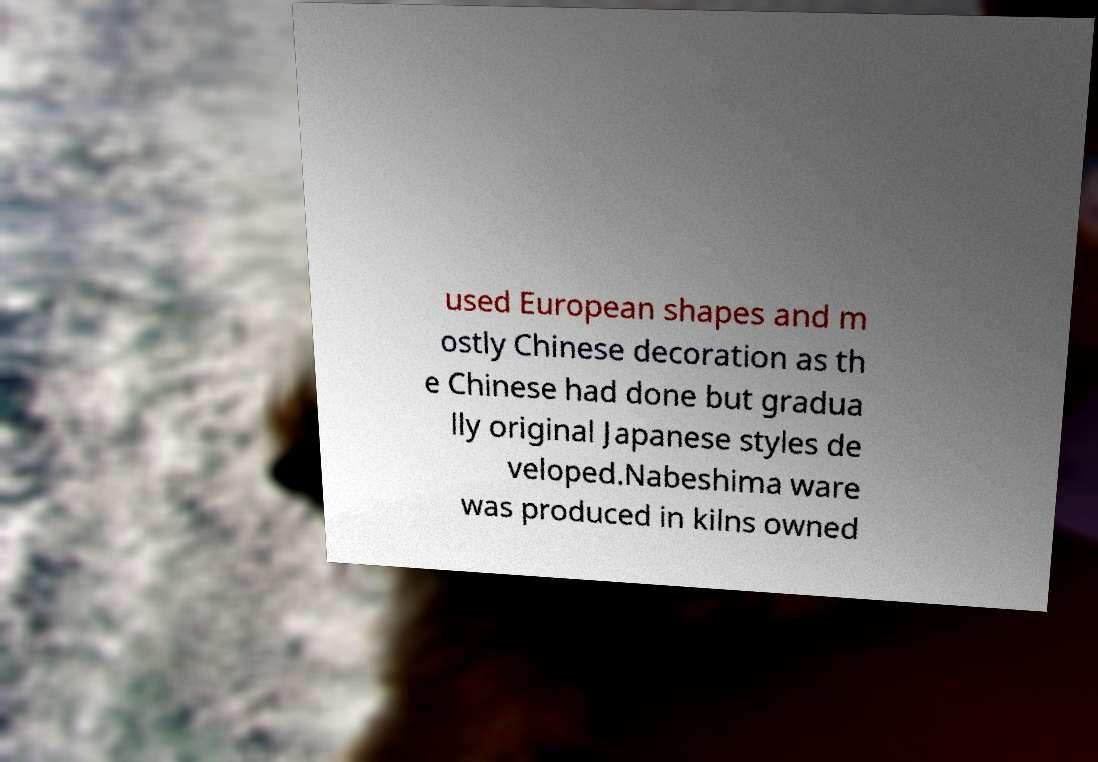Could you extract and type out the text from this image? used European shapes and m ostly Chinese decoration as th e Chinese had done but gradua lly original Japanese styles de veloped.Nabeshima ware was produced in kilns owned 